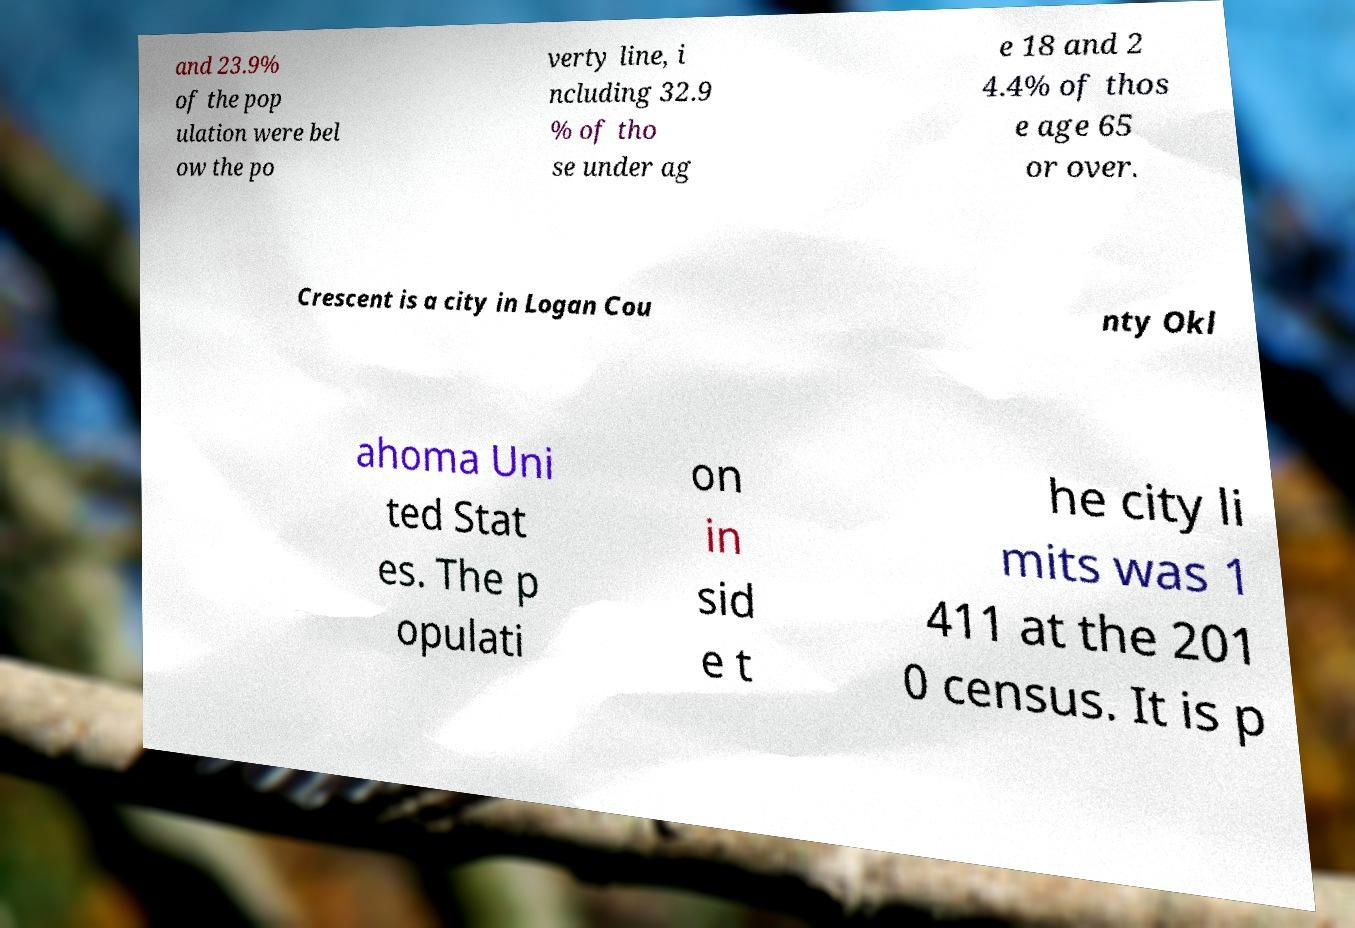For documentation purposes, I need the text within this image transcribed. Could you provide that? and 23.9% of the pop ulation were bel ow the po verty line, i ncluding 32.9 % of tho se under ag e 18 and 2 4.4% of thos e age 65 or over. Crescent is a city in Logan Cou nty Okl ahoma Uni ted Stat es. The p opulati on in sid e t he city li mits was 1 411 at the 201 0 census. It is p 